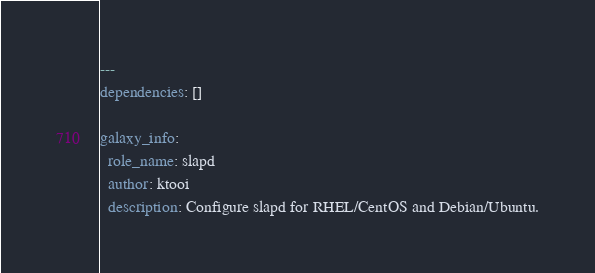Convert code to text. <code><loc_0><loc_0><loc_500><loc_500><_YAML_>---
dependencies: []

galaxy_info:
  role_name: slapd
  author: ktooi
  description: Configure slapd for RHEL/CentOS and Debian/Ubuntu.</code> 